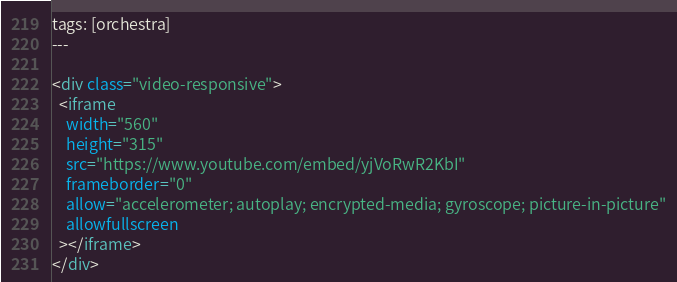<code> <loc_0><loc_0><loc_500><loc_500><_HTML_>tags: [orchestra]
---

<div class="video-responsive">
  <iframe
    width="560"
    height="315"
    src="https://www.youtube.com/embed/yjVoRwR2KbI"
    frameborder="0"
    allow="accelerometer; autoplay; encrypted-media; gyroscope; picture-in-picture"
    allowfullscreen
  ></iframe>
</div>
</code> 